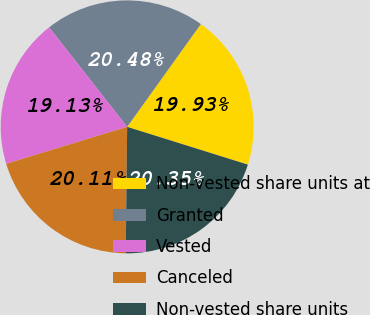<chart> <loc_0><loc_0><loc_500><loc_500><pie_chart><fcel>Non-vested share units at<fcel>Granted<fcel>Vested<fcel>Canceled<fcel>Non-vested share units<nl><fcel>19.93%<fcel>20.48%<fcel>19.13%<fcel>20.11%<fcel>20.35%<nl></chart> 